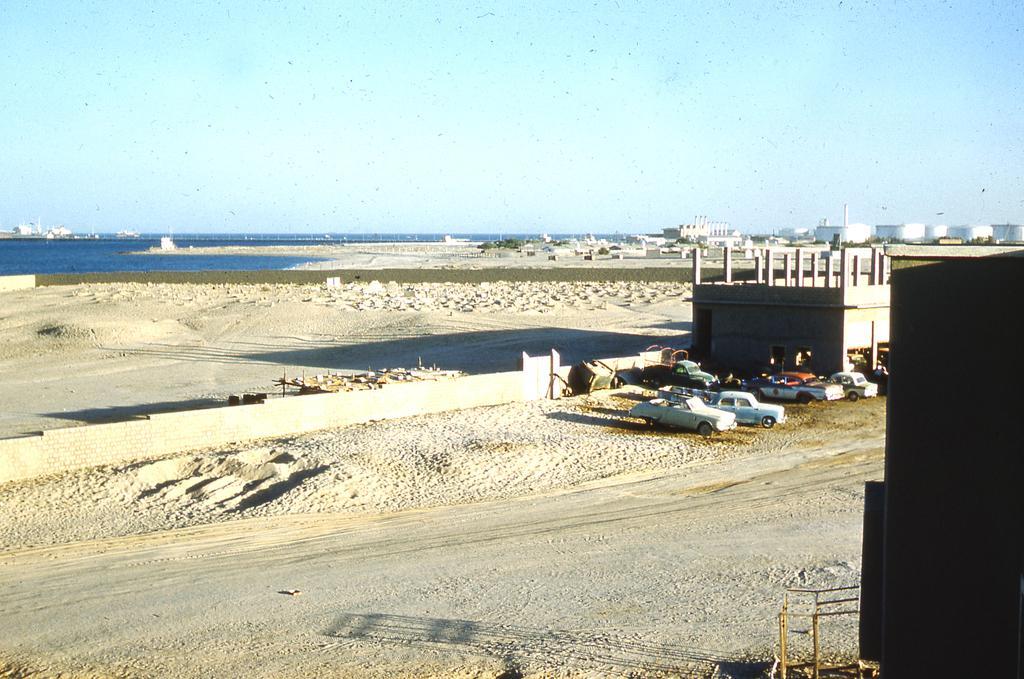How would you summarize this image in a sentence or two? In this image we can see some vehicles parked on the ground. On the right side of the image we can see buildings and some poles. In the center of the image we can see a wall. On the left side of the image we can see water. At the top of the image we can see the sky. 